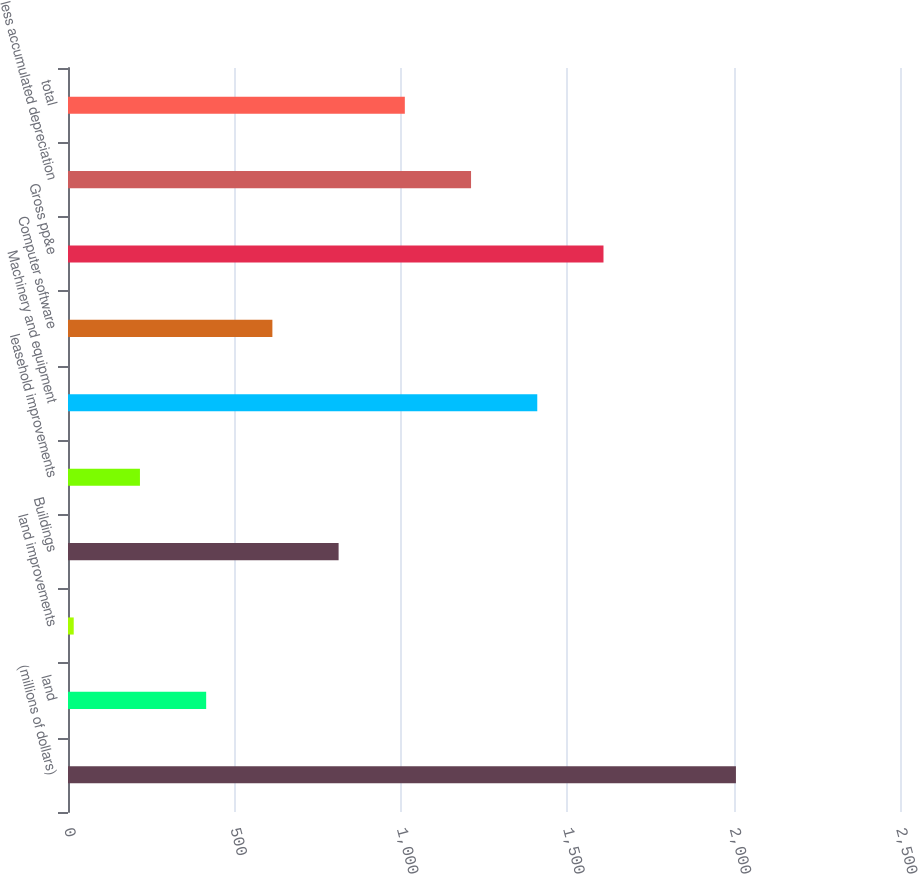Convert chart to OTSL. <chart><loc_0><loc_0><loc_500><loc_500><bar_chart><fcel>(millions of dollars)<fcel>land<fcel>land improvements<fcel>Buildings<fcel>leasehold improvements<fcel>Machinery and equipment<fcel>Computer software<fcel>Gross pp&e<fcel>less accumulated depreciation<fcel>total<nl><fcel>2007<fcel>415.16<fcel>17.2<fcel>813.12<fcel>216.18<fcel>1410.06<fcel>614.14<fcel>1609.04<fcel>1211.08<fcel>1012.1<nl></chart> 